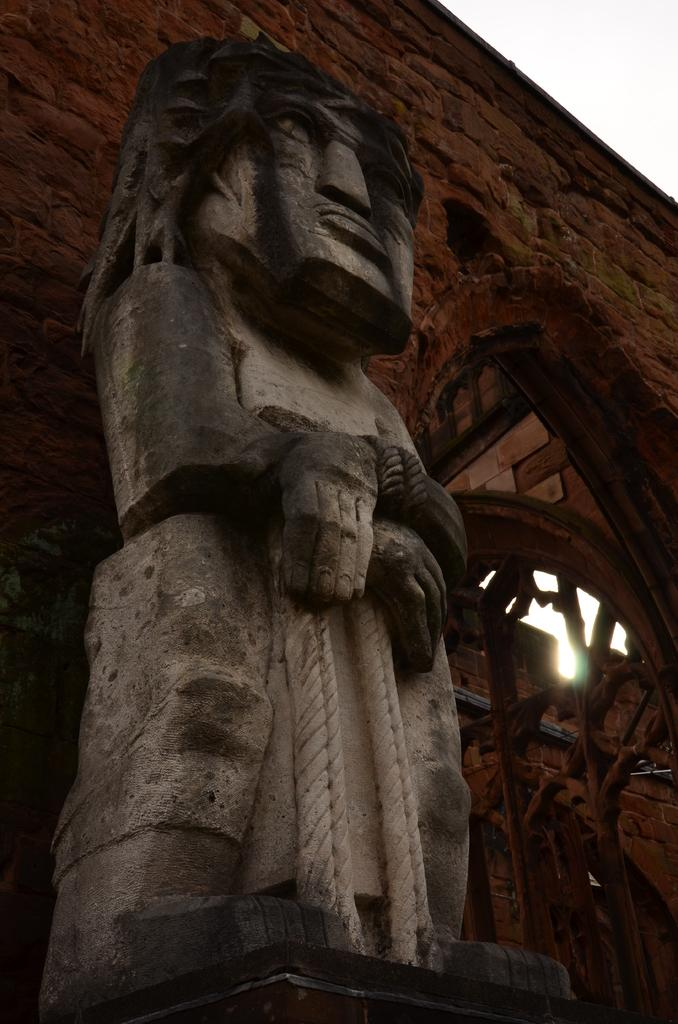What is the main subject in the image? There is a statue in the image. What can be seen in the background of the image? There is a building in the background of the image. How would you describe the weather based on the image? The sky is clear in the image, suggesting good weather. What type of paste is being used to hold the statue together in the image? There is no indication in the image that the statue is made of or held together by any paste. 